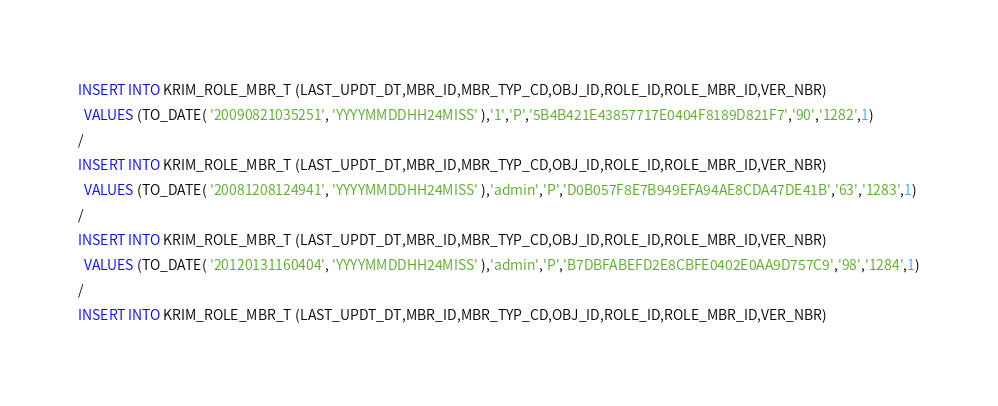<code> <loc_0><loc_0><loc_500><loc_500><_SQL_>
INSERT INTO KRIM_ROLE_MBR_T (LAST_UPDT_DT,MBR_ID,MBR_TYP_CD,OBJ_ID,ROLE_ID,ROLE_MBR_ID,VER_NBR)
  VALUES (TO_DATE( '20090821035251', 'YYYYMMDDHH24MISS' ),'1','P','5B4B421E43857717E0404F8189D821F7','90','1282',1)
/
INSERT INTO KRIM_ROLE_MBR_T (LAST_UPDT_DT,MBR_ID,MBR_TYP_CD,OBJ_ID,ROLE_ID,ROLE_MBR_ID,VER_NBR)
  VALUES (TO_DATE( '20081208124941', 'YYYYMMDDHH24MISS' ),'admin','P','D0B057F8E7B949EFA94AE8CDA47DE41B','63','1283',1)
/
INSERT INTO KRIM_ROLE_MBR_T (LAST_UPDT_DT,MBR_ID,MBR_TYP_CD,OBJ_ID,ROLE_ID,ROLE_MBR_ID,VER_NBR)
  VALUES (TO_DATE( '20120131160404', 'YYYYMMDDHH24MISS' ),'admin','P','B7DBFABEFD2E8CBFE0402E0AA9D757C9','98','1284',1)
/
INSERT INTO KRIM_ROLE_MBR_T (LAST_UPDT_DT,MBR_ID,MBR_TYP_CD,OBJ_ID,ROLE_ID,ROLE_MBR_ID,VER_NBR)</code> 